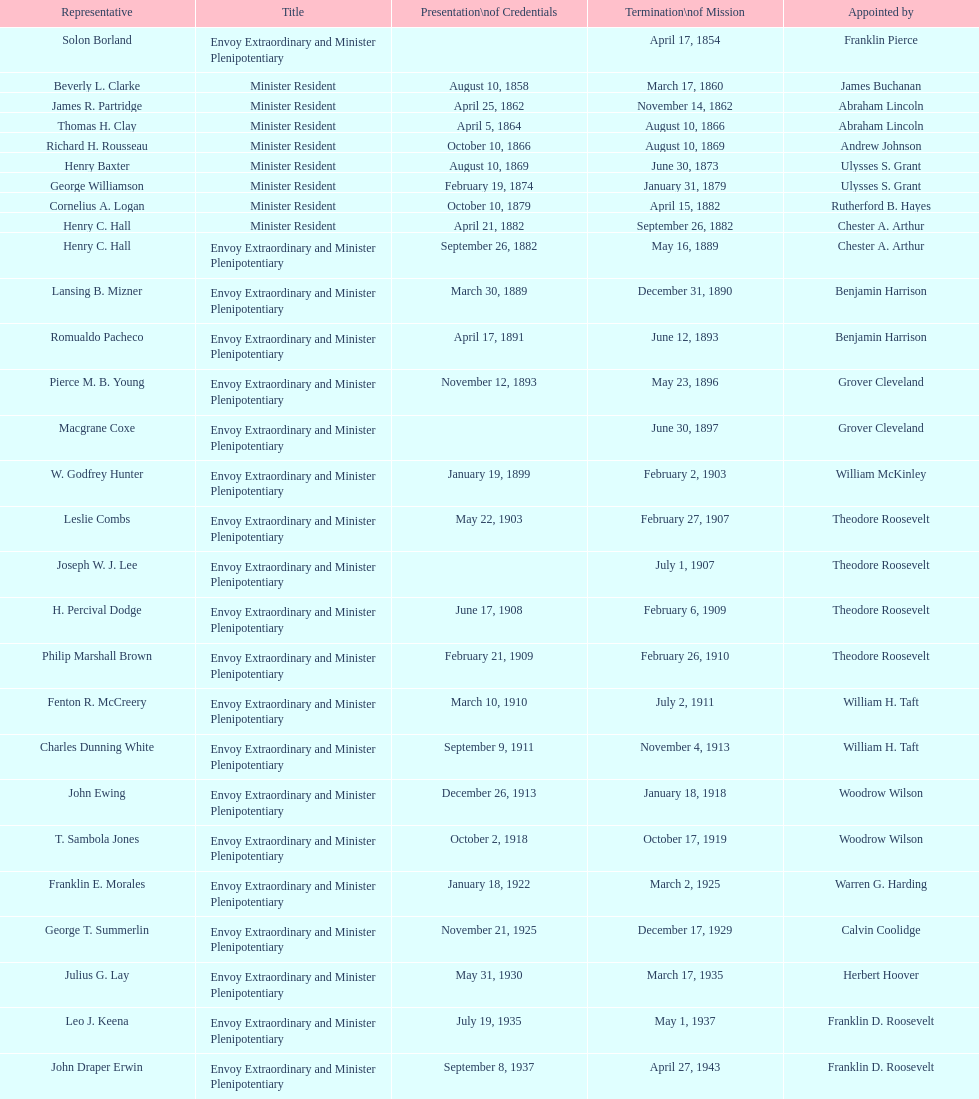What is the overall number of representatives that have existed? 50. 